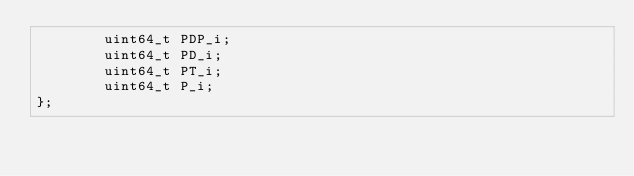Convert code to text. <code><loc_0><loc_0><loc_500><loc_500><_C_>        uint64_t PDP_i;
        uint64_t PD_i;
        uint64_t PT_i;
        uint64_t P_i;
};</code> 